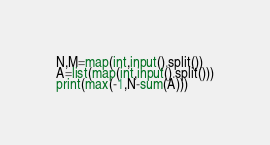<code> <loc_0><loc_0><loc_500><loc_500><_Python_>N,M=map(int,input().split())
A=list(map(int,input().split()))
print(max(-1,N-sum(A)))</code> 